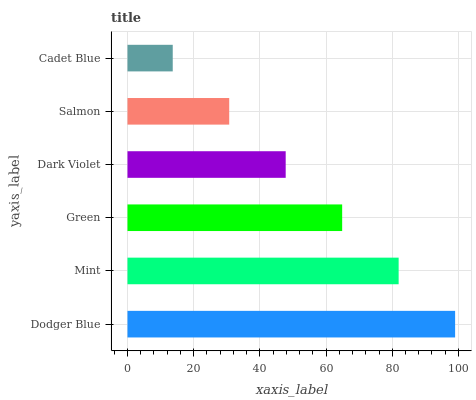Is Cadet Blue the minimum?
Answer yes or no. Yes. Is Dodger Blue the maximum?
Answer yes or no. Yes. Is Mint the minimum?
Answer yes or no. No. Is Mint the maximum?
Answer yes or no. No. Is Dodger Blue greater than Mint?
Answer yes or no. Yes. Is Mint less than Dodger Blue?
Answer yes or no. Yes. Is Mint greater than Dodger Blue?
Answer yes or no. No. Is Dodger Blue less than Mint?
Answer yes or no. No. Is Green the high median?
Answer yes or no. Yes. Is Dark Violet the low median?
Answer yes or no. Yes. Is Mint the high median?
Answer yes or no. No. Is Dodger Blue the low median?
Answer yes or no. No. 